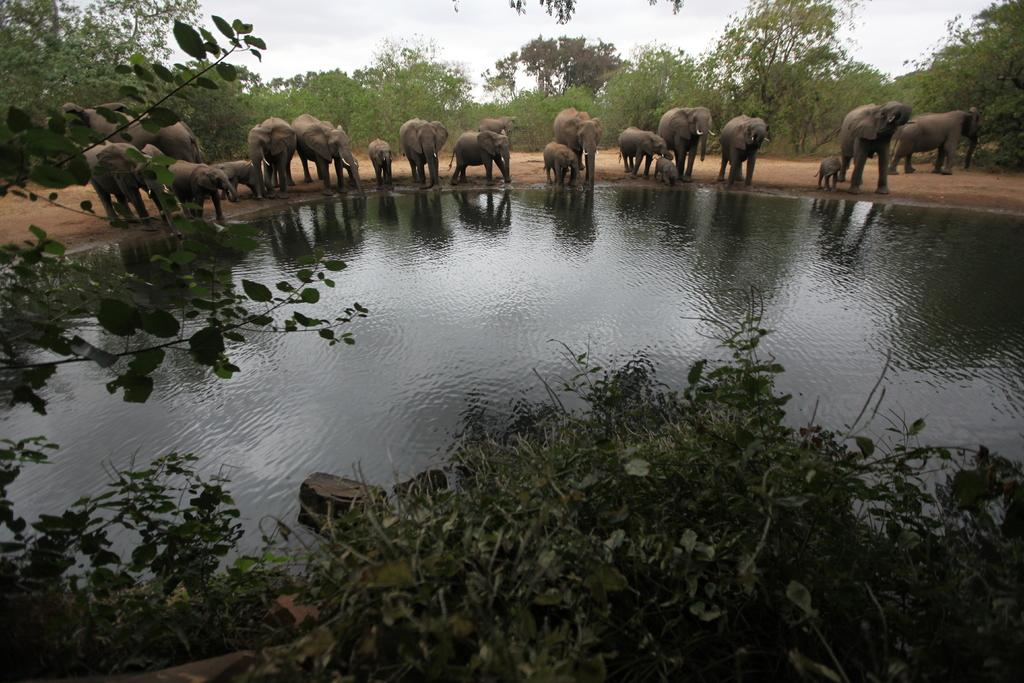What animals are present on the ground in the image? There are elephants on the ground in the image. What is near the elephants? There is water near the elephants. What can be seen in the background of the image? There are trees and the sky visible in the background of the image. What type of doll can be seen playing with cars in the image? There is no doll or cars present in the image; it features elephants on the ground with water nearby and trees and sky in the background. 